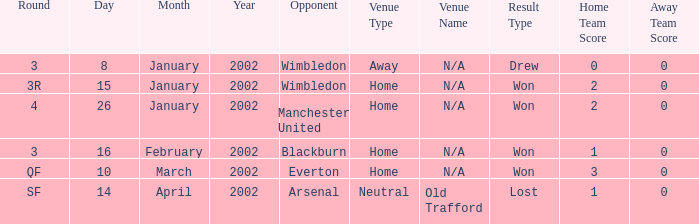What is the date of encountering a rival in wimbledon, with an outcome of 0-0 draw? 8 January 2002. Would you be able to parse every entry in this table? {'header': ['Round', 'Day', 'Month', 'Year', 'Opponent', 'Venue Type', 'Venue Name', 'Result Type', 'Home Team Score', 'Away Team Score'], 'rows': [['3', '8', 'January', '2002', 'Wimbledon', 'Away', 'N/A', 'Drew', '0', '0'], ['3R', '15', 'January', '2002', 'Wimbledon', 'Home', 'N/A', 'Won', '2', '0'], ['4', '26', 'January', '2002', 'Manchester United', 'Home', 'N/A', 'Won', '2', '0'], ['3', '16', 'February', '2002', 'Blackburn', 'Home', 'N/A', 'Won', '1', '0'], ['QF', '10', 'March', '2002', 'Everton', 'Home', 'N/A', 'Won', '3', '0'], ['SF', '14', 'April', '2002', 'Arsenal', 'Neutral', 'Old Trafford', 'Lost', '1', '0']]} 